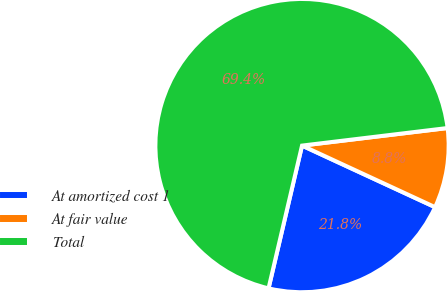Convert chart to OTSL. <chart><loc_0><loc_0><loc_500><loc_500><pie_chart><fcel>At amortized cost 1<fcel>At fair value<fcel>Total<nl><fcel>21.77%<fcel>8.81%<fcel>69.42%<nl></chart> 